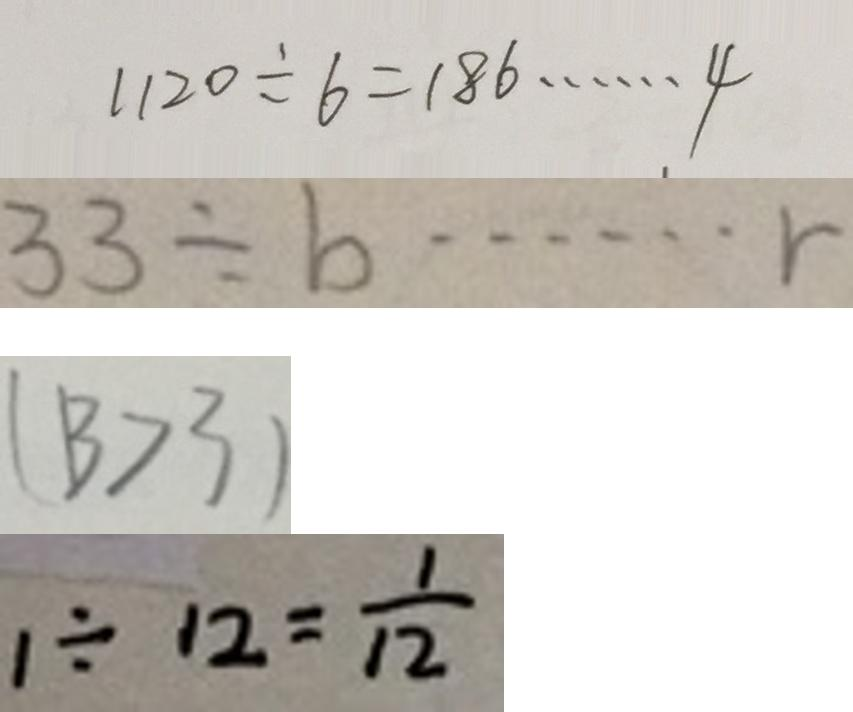Convert formula to latex. <formula><loc_0><loc_0><loc_500><loc_500>1 1 2 0 \div 6 = 1 8 6 \cdots 4 
 3 3 \div b \cdots r 
 ( 1 3 > 3 ) 
 1 \div 1 2 = \frac { 1 } { 1 2 }</formula> 